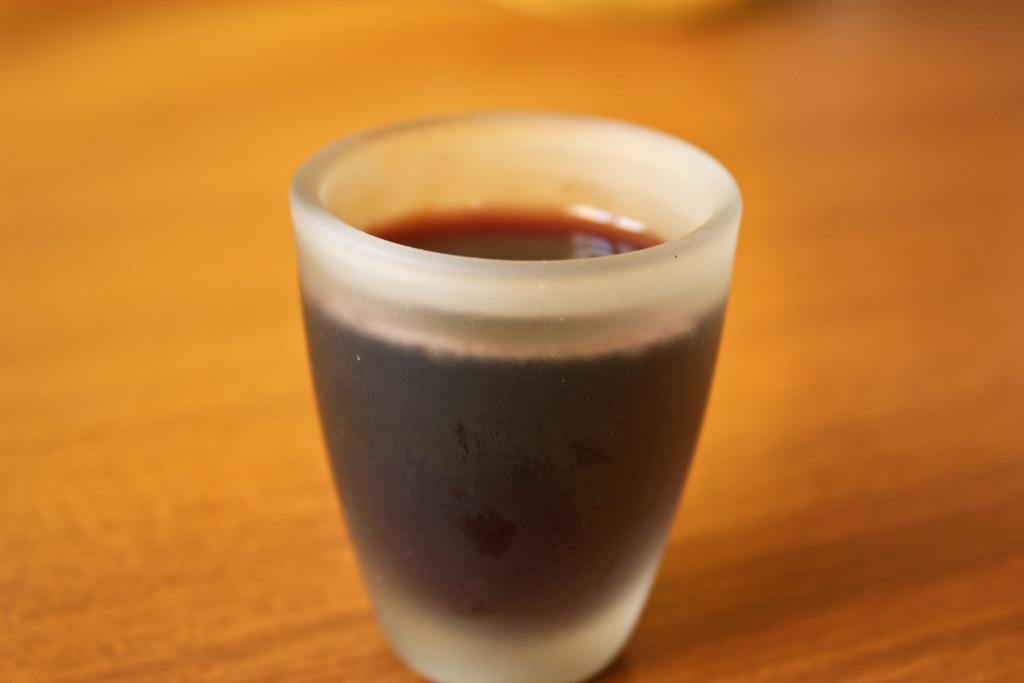Describe this image in one or two sentences. In the center of the image we can see one table. On the table, we can see one glass. In the glass, we can see water, which is in brown color. 